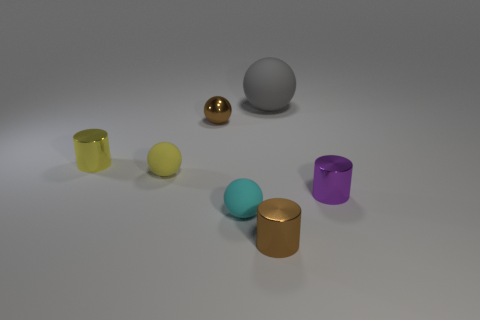There is a purple shiny thing that is the same size as the yellow rubber object; what shape is it?
Your answer should be compact. Cylinder. What is the material of the brown sphere?
Your response must be concise. Metal. The rubber thing that is both right of the small metal ball and in front of the gray rubber object is what color?
Ensure brevity in your answer.  Cyan. Is the number of tiny yellow objects to the right of the small brown sphere the same as the number of tiny brown things on the right side of the small yellow rubber ball?
Offer a terse response. No. There is a large thing that is made of the same material as the small yellow ball; what color is it?
Keep it short and to the point. Gray. Does the large sphere have the same color as the tiny sphere on the left side of the small brown metallic sphere?
Ensure brevity in your answer.  No. Is there a yellow matte object that is in front of the brown shiny object on the right side of the tiny matte object in front of the small yellow matte thing?
Offer a very short reply. No. The yellow object that is made of the same material as the big gray thing is what shape?
Ensure brevity in your answer.  Sphere. What shape is the small cyan object?
Your response must be concise. Sphere. There is a rubber thing that is right of the tiny brown shiny cylinder; is its shape the same as the yellow rubber thing?
Your answer should be very brief. Yes. 